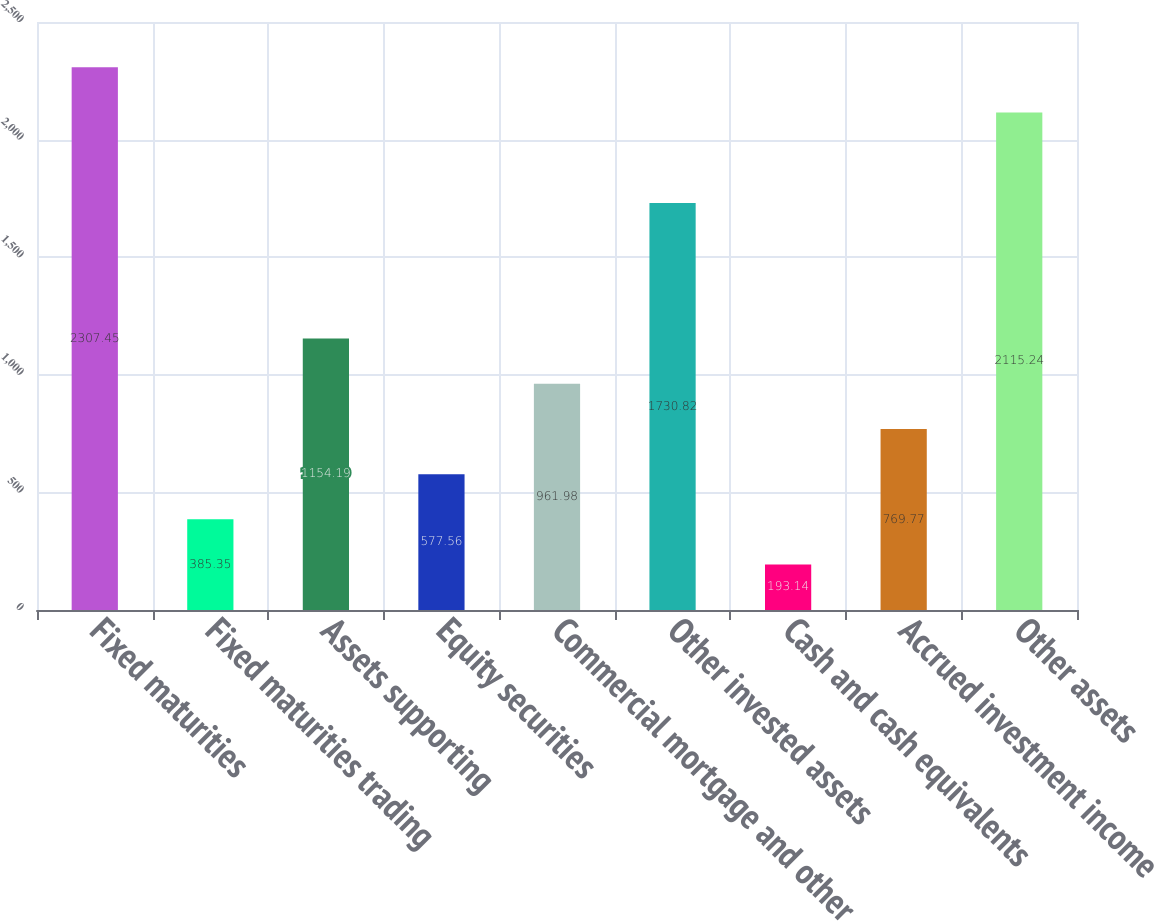Convert chart to OTSL. <chart><loc_0><loc_0><loc_500><loc_500><bar_chart><fcel>Fixed maturities<fcel>Fixed maturities trading<fcel>Assets supporting<fcel>Equity securities<fcel>Commercial mortgage and other<fcel>Other invested assets<fcel>Cash and cash equivalents<fcel>Accrued investment income<fcel>Other assets<nl><fcel>2307.45<fcel>385.35<fcel>1154.19<fcel>577.56<fcel>961.98<fcel>1730.82<fcel>193.14<fcel>769.77<fcel>2115.24<nl></chart> 